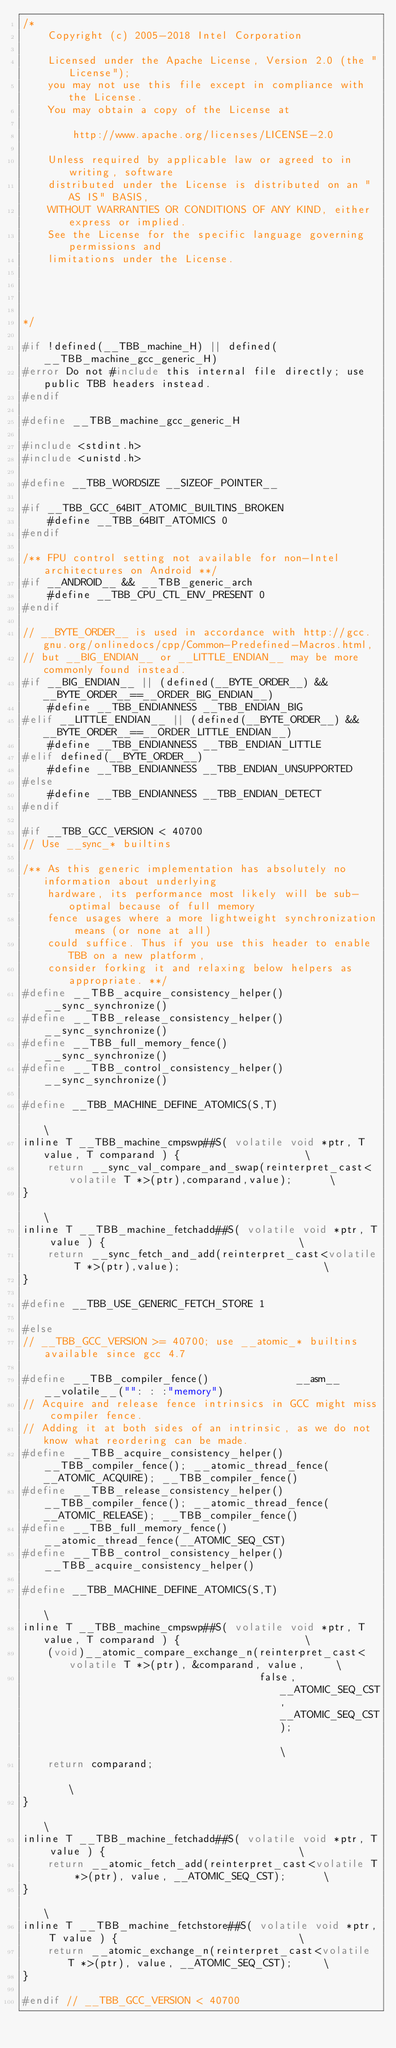<code> <loc_0><loc_0><loc_500><loc_500><_C_>/*
    Copyright (c) 2005-2018 Intel Corporation

    Licensed under the Apache License, Version 2.0 (the "License");
    you may not use this file except in compliance with the License.
    You may obtain a copy of the License at

        http://www.apache.org/licenses/LICENSE-2.0

    Unless required by applicable law or agreed to in writing, software
    distributed under the License is distributed on an "AS IS" BASIS,
    WITHOUT WARRANTIES OR CONDITIONS OF ANY KIND, either express or implied.
    See the License for the specific language governing permissions and
    limitations under the License.




*/

#if !defined(__TBB_machine_H) || defined(__TBB_machine_gcc_generic_H)
#error Do not #include this internal file directly; use public TBB headers instead.
#endif

#define __TBB_machine_gcc_generic_H

#include <stdint.h>
#include <unistd.h>

#define __TBB_WORDSIZE __SIZEOF_POINTER__

#if __TBB_GCC_64BIT_ATOMIC_BUILTINS_BROKEN
    #define __TBB_64BIT_ATOMICS 0
#endif

/** FPU control setting not available for non-Intel architectures on Android **/
#if __ANDROID__ && __TBB_generic_arch
    #define __TBB_CPU_CTL_ENV_PRESENT 0
#endif

// __BYTE_ORDER__ is used in accordance with http://gcc.gnu.org/onlinedocs/cpp/Common-Predefined-Macros.html,
// but __BIG_ENDIAN__ or __LITTLE_ENDIAN__ may be more commonly found instead.
#if __BIG_ENDIAN__ || (defined(__BYTE_ORDER__) && __BYTE_ORDER__==__ORDER_BIG_ENDIAN__)
    #define __TBB_ENDIANNESS __TBB_ENDIAN_BIG
#elif __LITTLE_ENDIAN__ || (defined(__BYTE_ORDER__) && __BYTE_ORDER__==__ORDER_LITTLE_ENDIAN__)
    #define __TBB_ENDIANNESS __TBB_ENDIAN_LITTLE
#elif defined(__BYTE_ORDER__)
    #define __TBB_ENDIANNESS __TBB_ENDIAN_UNSUPPORTED
#else
    #define __TBB_ENDIANNESS __TBB_ENDIAN_DETECT
#endif

#if __TBB_GCC_VERSION < 40700
// Use __sync_* builtins

/** As this generic implementation has absolutely no information about underlying
    hardware, its performance most likely will be sub-optimal because of full memory
    fence usages where a more lightweight synchronization means (or none at all)
    could suffice. Thus if you use this header to enable TBB on a new platform,
    consider forking it and relaxing below helpers as appropriate. **/
#define __TBB_acquire_consistency_helper()  __sync_synchronize()
#define __TBB_release_consistency_helper()  __sync_synchronize()
#define __TBB_full_memory_fence()           __sync_synchronize()
#define __TBB_control_consistency_helper()  __sync_synchronize()

#define __TBB_MACHINE_DEFINE_ATOMICS(S,T)                                                         \
inline T __TBB_machine_cmpswp##S( volatile void *ptr, T value, T comparand ) {                    \
    return __sync_val_compare_and_swap(reinterpret_cast<volatile T *>(ptr),comparand,value);      \
}                                                                                                 \
inline T __TBB_machine_fetchadd##S( volatile void *ptr, T value ) {                               \
    return __sync_fetch_and_add(reinterpret_cast<volatile T *>(ptr),value);                       \
}

#define __TBB_USE_GENERIC_FETCH_STORE 1

#else
// __TBB_GCC_VERSION >= 40700; use __atomic_* builtins available since gcc 4.7

#define __TBB_compiler_fence()              __asm__ __volatile__("": : :"memory")
// Acquire and release fence intrinsics in GCC might miss compiler fence.
// Adding it at both sides of an intrinsic, as we do not know what reordering can be made.
#define __TBB_acquire_consistency_helper()  __TBB_compiler_fence(); __atomic_thread_fence(__ATOMIC_ACQUIRE); __TBB_compiler_fence()
#define __TBB_release_consistency_helper()  __TBB_compiler_fence(); __atomic_thread_fence(__ATOMIC_RELEASE); __TBB_compiler_fence()
#define __TBB_full_memory_fence()           __atomic_thread_fence(__ATOMIC_SEQ_CST)
#define __TBB_control_consistency_helper()  __TBB_acquire_consistency_helper()

#define __TBB_MACHINE_DEFINE_ATOMICS(S,T)                                                         \
inline T __TBB_machine_cmpswp##S( volatile void *ptr, T value, T comparand ) {                    \
    (void)__atomic_compare_exchange_n(reinterpret_cast<volatile T *>(ptr), &comparand, value,     \
                                      false, __ATOMIC_SEQ_CST, __ATOMIC_SEQ_CST);                 \
    return comparand;                                                                             \
}                                                                                                 \
inline T __TBB_machine_fetchadd##S( volatile void *ptr, T value ) {                               \
    return __atomic_fetch_add(reinterpret_cast<volatile T *>(ptr), value, __ATOMIC_SEQ_CST);      \
}                                                                                                 \
inline T __TBB_machine_fetchstore##S( volatile void *ptr, T value ) {                             \
    return __atomic_exchange_n(reinterpret_cast<volatile T *>(ptr), value, __ATOMIC_SEQ_CST);     \
}

#endif // __TBB_GCC_VERSION < 40700
</code> 